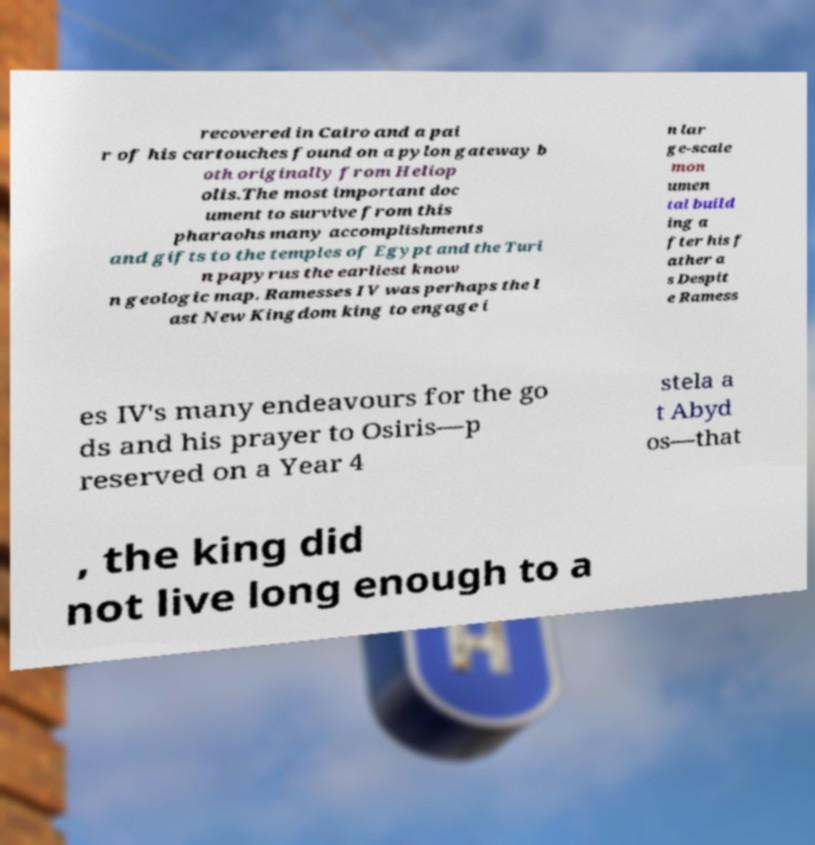There's text embedded in this image that I need extracted. Can you transcribe it verbatim? recovered in Cairo and a pai r of his cartouches found on a pylon gateway b oth originally from Heliop olis.The most important doc ument to survive from this pharaohs many accomplishments and gifts to the temples of Egypt and the Turi n papyrus the earliest know n geologic map. Ramesses IV was perhaps the l ast New Kingdom king to engage i n lar ge-scale mon umen tal build ing a fter his f ather a s Despit e Ramess es IV's many endeavours for the go ds and his prayer to Osiris—p reserved on a Year 4 stela a t Abyd os—that , the king did not live long enough to a 